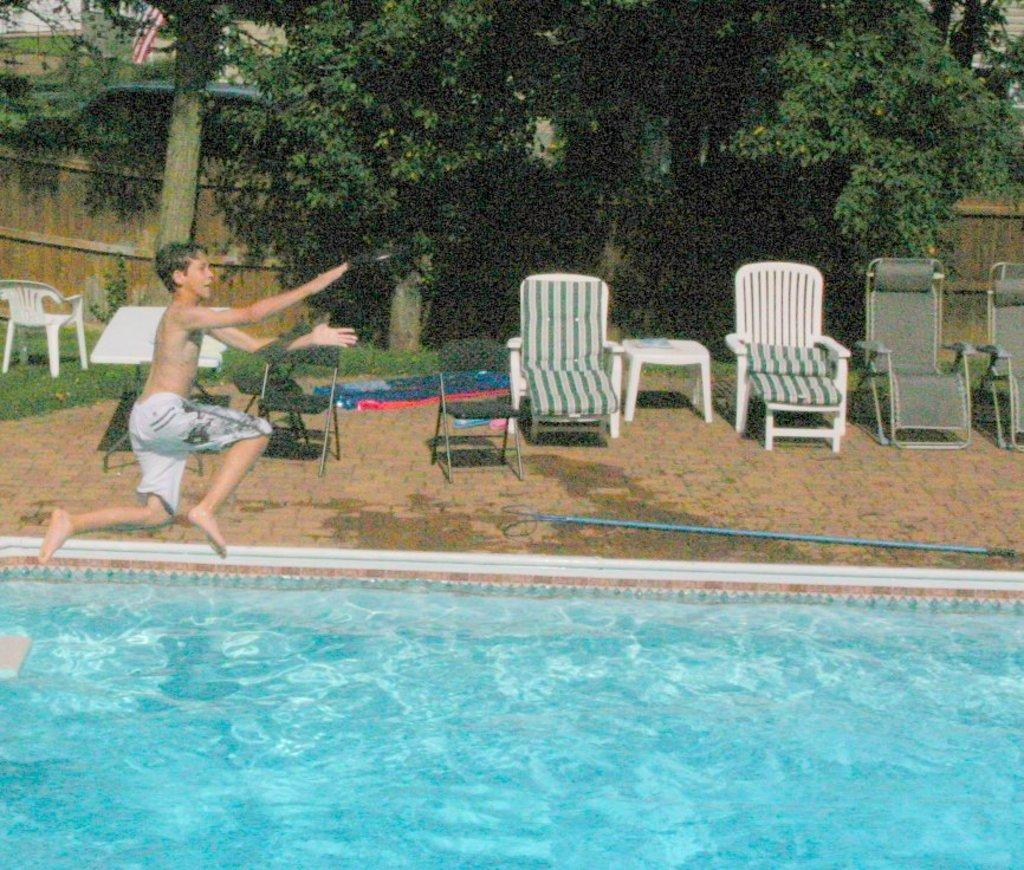What is the main subject of the image? There is a person in the image. What is the person doing in the image? The person is jumping into the water. Are there any objects or furniture in the image? Yes, there are chairs in the image. What can be seen in the background of the image? There are trees visible in the background of the image. What type of twist can be seen in the person's hair in the image? There is no mention of the person's hair or any twist in the provided facts, so we cannot answer this question. 